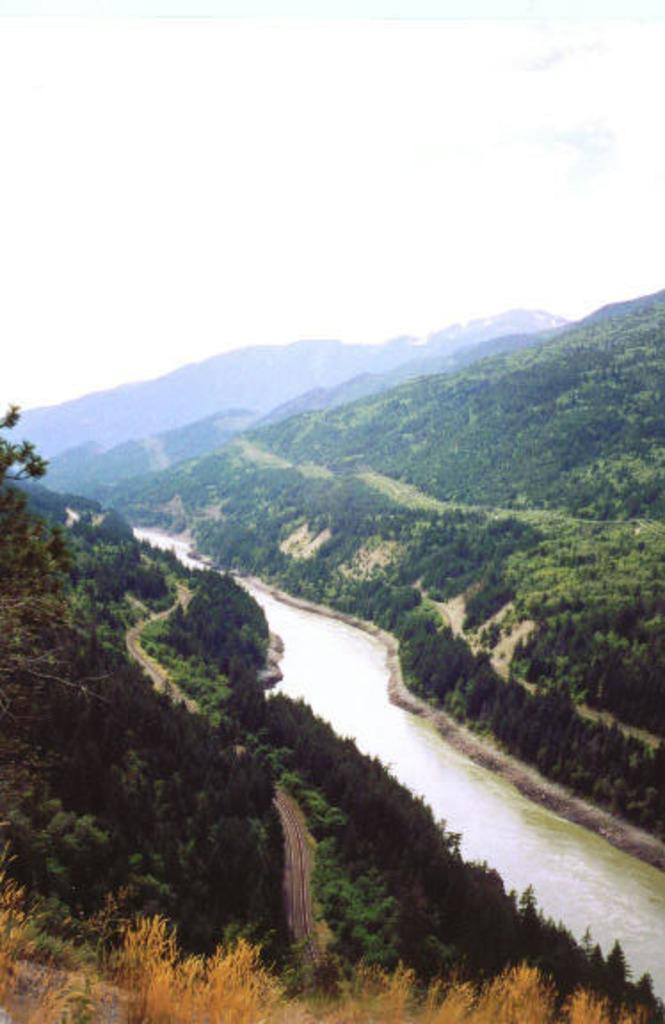What is the primary element visible in the image? There is water in the image. What type of vegetation can be seen in the image? There are trees in the image. What can be seen in the background of the image? The sky is visible in the background of the image. What color of yarn is being used to create the sheet in the image? There is no yarn or sheet present in the image. 